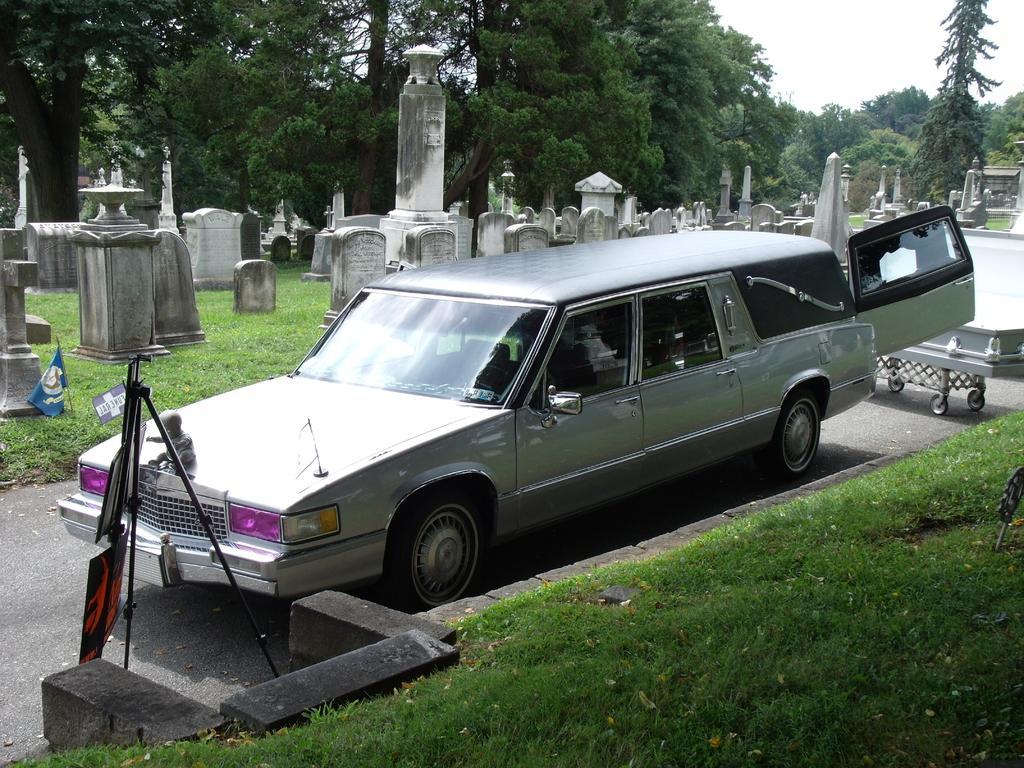How would you summarize this image in a sentence or two? In the middle of this image, there is a gray color vehicle on a road. On the right side, there's grass on the ground. In the background, there are trees, graves and grass on the ground and there is sky. 